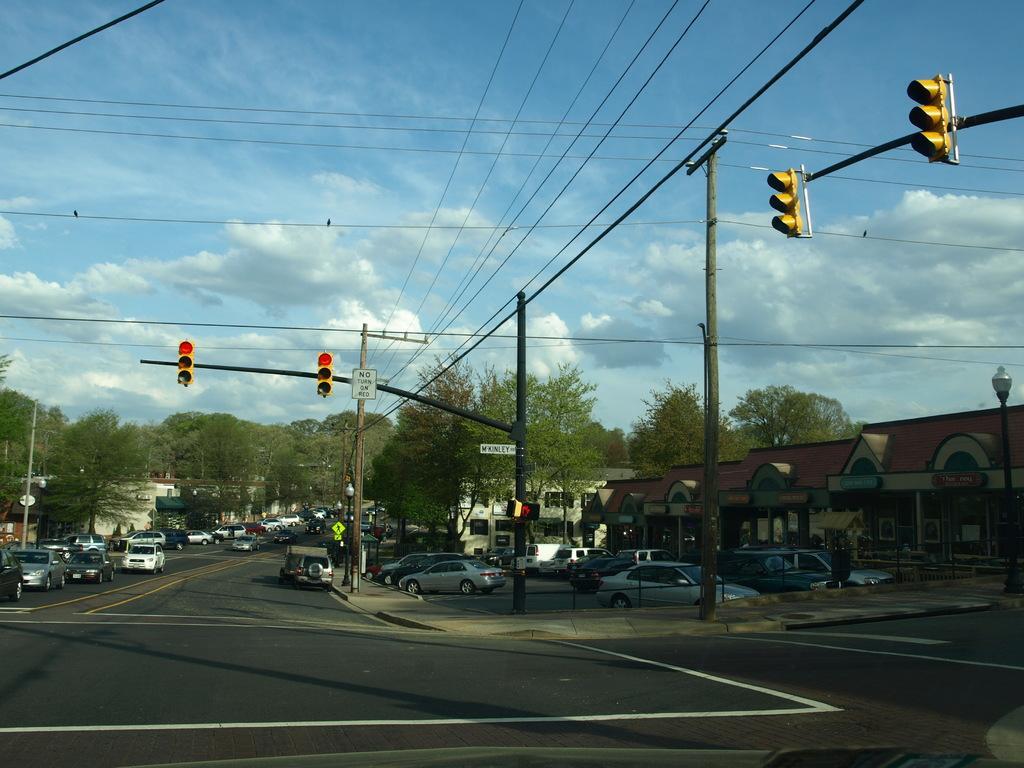Please provide a concise description of this image. In this image there are cars on the road. There are traffic lights, street lights, current poles with wires. There are directional boards. In the background of the image there are trees, buildings and sky. 